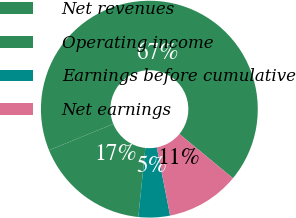Convert chart. <chart><loc_0><loc_0><loc_500><loc_500><pie_chart><fcel>Net revenues<fcel>Operating income<fcel>Earnings before cumulative<fcel>Net earnings<nl><fcel>67.18%<fcel>17.19%<fcel>4.69%<fcel>10.94%<nl></chart> 